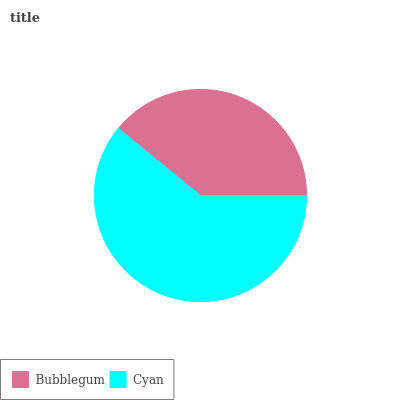Is Bubblegum the minimum?
Answer yes or no. Yes. Is Cyan the maximum?
Answer yes or no. Yes. Is Cyan the minimum?
Answer yes or no. No. Is Cyan greater than Bubblegum?
Answer yes or no. Yes. Is Bubblegum less than Cyan?
Answer yes or no. Yes. Is Bubblegum greater than Cyan?
Answer yes or no. No. Is Cyan less than Bubblegum?
Answer yes or no. No. Is Cyan the high median?
Answer yes or no. Yes. Is Bubblegum the low median?
Answer yes or no. Yes. Is Bubblegum the high median?
Answer yes or no. No. Is Cyan the low median?
Answer yes or no. No. 